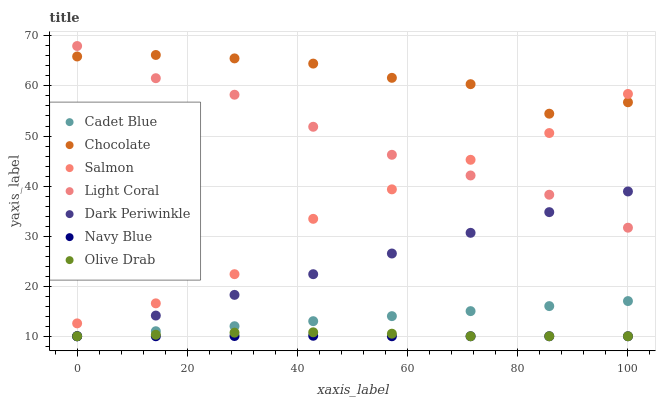Does Navy Blue have the minimum area under the curve?
Answer yes or no. Yes. Does Chocolate have the maximum area under the curve?
Answer yes or no. Yes. Does Salmon have the minimum area under the curve?
Answer yes or no. No. Does Salmon have the maximum area under the curve?
Answer yes or no. No. Is Cadet Blue the smoothest?
Answer yes or no. Yes. Is Chocolate the roughest?
Answer yes or no. Yes. Is Navy Blue the smoothest?
Answer yes or no. No. Is Navy Blue the roughest?
Answer yes or no. No. Does Cadet Blue have the lowest value?
Answer yes or no. Yes. Does Salmon have the lowest value?
Answer yes or no. No. Does Light Coral have the highest value?
Answer yes or no. Yes. Does Salmon have the highest value?
Answer yes or no. No. Is Dark Periwinkle less than Salmon?
Answer yes or no. Yes. Is Salmon greater than Navy Blue?
Answer yes or no. Yes. Does Dark Periwinkle intersect Olive Drab?
Answer yes or no. Yes. Is Dark Periwinkle less than Olive Drab?
Answer yes or no. No. Is Dark Periwinkle greater than Olive Drab?
Answer yes or no. No. Does Dark Periwinkle intersect Salmon?
Answer yes or no. No. 